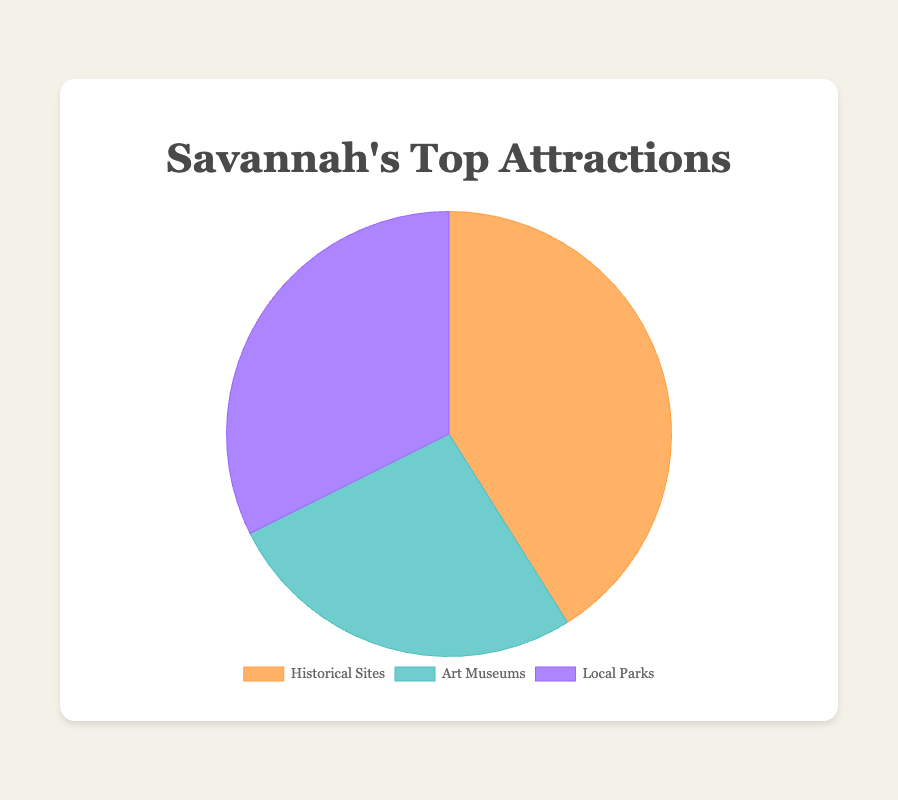What is the combined visitor count for historical sites? The historical sites in the figure include the Savannah Historic District and the Wormsloe Historic Site. Their visitor counts are 350,000 and 75,000 respectively. Combining these two numbers (350,000 + 75,000) gives a total of 425,000 visitors.
Answer: 425,000 Which attraction type has the highest visitor count? The figure shows the visitor counts for the three attraction types. By comparing their total counts: Historical Sites (425,000), Art Museums (275,000), and Local Parks (335,000), we see that Historical Sites have the highest visitor count.
Answer: Historical Sites What is the percentage of visitors that visited local parks? First, obtain the total number of visitors: Historical Sites (425,000), Art Museums (275,000), and Local Parks (335,000). Summing these up, we get a total of 1,035,000 visitors. The number of visitors to Local Parks is 335,000. The percentage is calculated as (335,000 / 1,035,000) * 100, which simplifies to approximately 32.4%.
Answer: 32.4% Which attraction type is represented by the green color in the pie chart? Observing the color representations in the pie chart, the green color is allocated to Local Parks.
Answer: Local Parks How many more visitors do the Savannah Historic District and Telfair Museums have compared to Forsyth Park? The visitor counts are: Savannah Historic District (350,000), Telfair Museums (150,000), Forsyth Park (250,000). Summing the visitors of the Savannah Historic District and Telfair Museums (350,000 + 150,000 = 500,000) and comparing with Forsyth Park (250,000), we find that 500,000 - 250,000 = 250,000 more visitors visited the first two compared to Forsyth Park.
Answer: 250,000 What is the average number of visitors for Art Museums? There are two Art Museums: Telfair Museums (150,000) and SCAD Museum of Art (125,000). The sum of their visitor counts is 275,000. Dividing this by 2 gives an average of 137,500 visitors.
Answer: 137,500 Is the combined visitor count for Skidaway Island State Park and SCAD Museum of Art greater than that of the Savannah Historic District? Skidaway Island State Park has 85,000 visitors and SCAD Museum of Art has 125,000 visitors. Their combined total is 85,000 + 125,000 = 210,000. The Savannah Historic District has 350,000 visitors, which is greater than 210,000.
Answer: No 